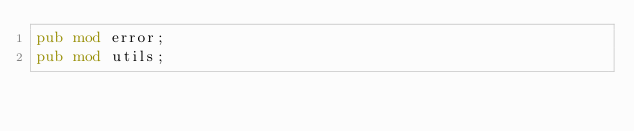<code> <loc_0><loc_0><loc_500><loc_500><_Rust_>pub mod error;
pub mod utils;
</code> 